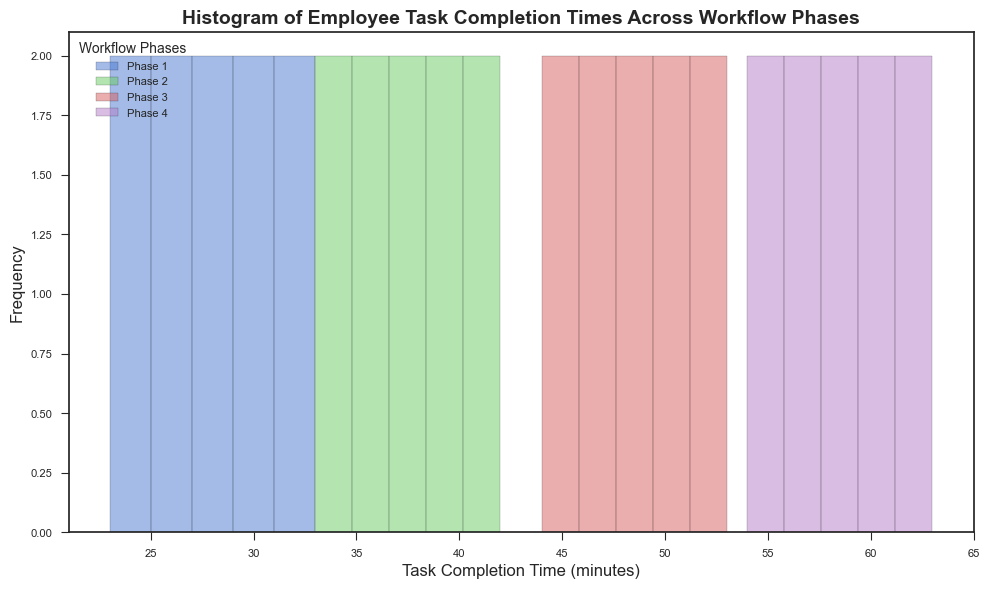What is the most frequent task completion time range in Phase 1? By observing the histogram bars for Phase 1, identify the range which has the highest bar. This indicates the most frequent or common task completion time.
Answer: 25-30 minutes Which workflow phase has the widest range of task completion times? Compare the width or spread of the histogram bars across all workflow phases. The phase with the widest range from the lowest to the highest value is the one with the widest range of task completion times.
Answer: Phase 4 Which phase has the highest peak frequency in terms of task completion times? Look for the phase with the tallest histogram bar, indicating the highest number of occurrences for a particular task completion time range.
Answer: Phase 4 Is the task completion time distribution wider in Phase 2 or Phase 3? Compare the spread of the histogram bars for Phase 2 and Phase 3. Determine which phase has a greater spread from the minimum to the maximum task completion time.
Answer: Phase 3 What is the average task completion time for Phase 3? Identify the midpoints of each time range for Phase 3, then calculate the average. Add up the midpoints multiplied by their respective frequencies and divide by the total number of tasks.
Answer: 48.5 minutes Which phase shows the least variation in task completion times? Analyze the spread and height of the histogram bars for each phase. The phase with the most consistently tall and narrow bars, with little variation from the lowest to the highest task completion time, has the least variation.
Answer: Phase 1 If combined, which two phases have the highest total number of tasks completed in their peak ranges? Identify the peak ranges (tallest bars) for each phase and sum the frequencies. Then find the combination of two phases that have the highest combined peak frequency.
Answer: Phase 3 and Phase 4 Which phase has a task completion time peaking at over 60 minutes? Observe if any phase's histogram extends into the 60+ minute range and has a peak in that range.
Answer: Phase 4 How does the distribution shape change from Phase 1 to Phase 4? Compare the histogram shapes of each phase, noting how the distribution widens, changes in peak height, and spreads out as you move from Phase 1 to Phase 4.
Answer: It widens and the peak height decreases What is the difference in the median task completion times between Phase 2 and Phase 4? Identify the median time range for each phase from the histogram, then calculate the difference between these median values.
Answer: 18 minutes 